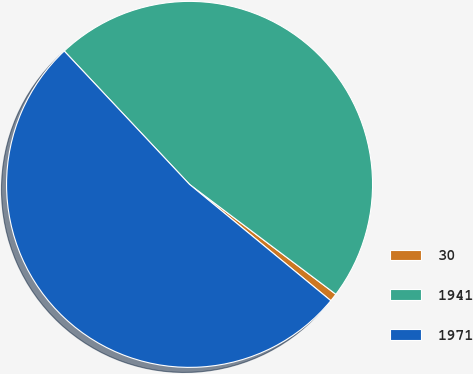Convert chart. <chart><loc_0><loc_0><loc_500><loc_500><pie_chart><fcel>30<fcel>1941<fcel>1971<nl><fcel>0.71%<fcel>47.26%<fcel>52.03%<nl></chart> 